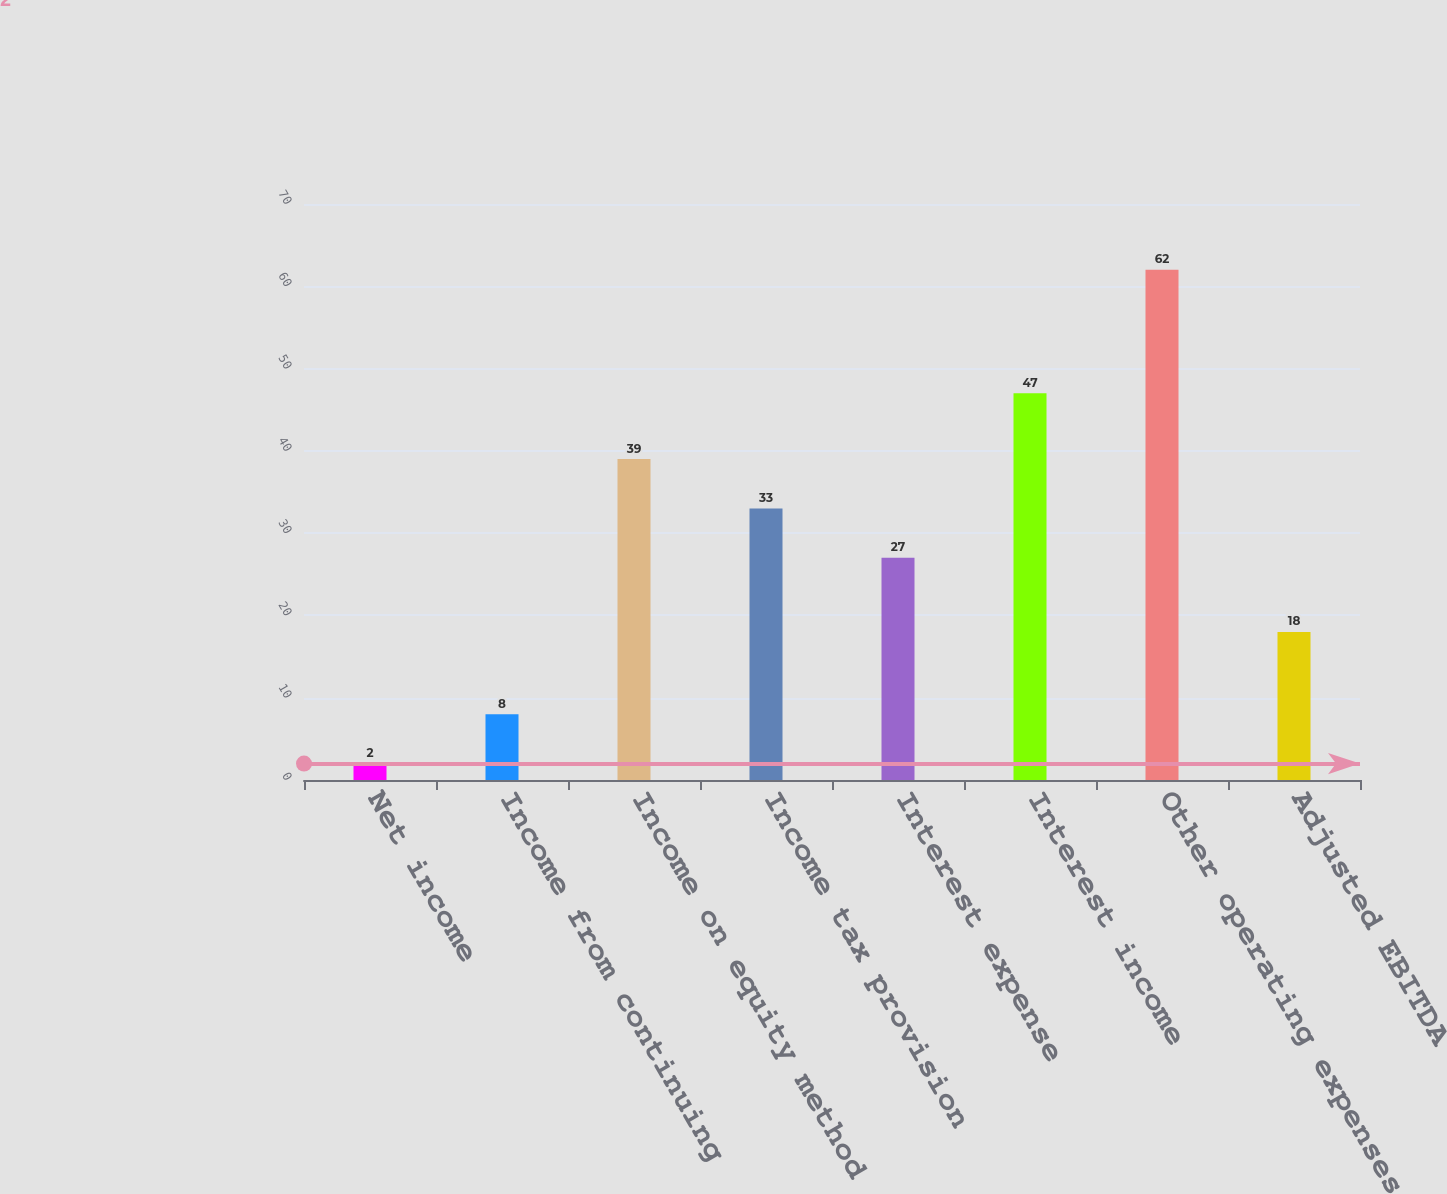Convert chart. <chart><loc_0><loc_0><loc_500><loc_500><bar_chart><fcel>Net income<fcel>Income from continuing<fcel>Income on equity method<fcel>Income tax provision<fcel>Interest expense<fcel>Interest income<fcel>Other operating expenses<fcel>Adjusted EBITDA<nl><fcel>2<fcel>8<fcel>39<fcel>33<fcel>27<fcel>47<fcel>62<fcel>18<nl></chart> 